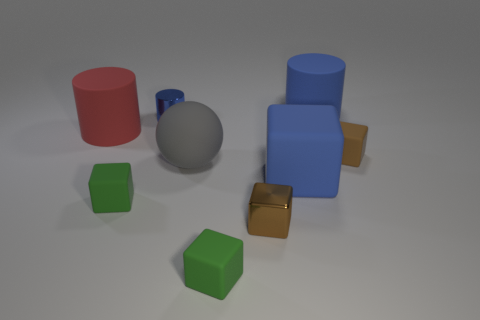Is there a green rubber object of the same shape as the small brown rubber thing?
Offer a very short reply. Yes. There is a block that is the same color as the small cylinder; what is it made of?
Make the answer very short. Rubber. How many rubber objects are gray blocks or tiny cylinders?
Offer a very short reply. 0. What shape is the tiny blue thing?
Make the answer very short. Cylinder. What number of large red objects are the same material as the small cylinder?
Your answer should be very brief. 0. There is a object that is made of the same material as the small blue cylinder; what is its color?
Your answer should be very brief. Brown. There is a green rubber cube that is to the right of the gray sphere; is it the same size as the big gray ball?
Keep it short and to the point. No. There is a large matte thing that is the same shape as the small brown shiny thing; what color is it?
Your answer should be compact. Blue. There is a gray matte thing that is behind the tiny brown object that is on the left side of the tiny brown object that is behind the large blue rubber block; what is its shape?
Offer a very short reply. Sphere. Is the shape of the big red matte object the same as the brown matte thing?
Your response must be concise. No. 